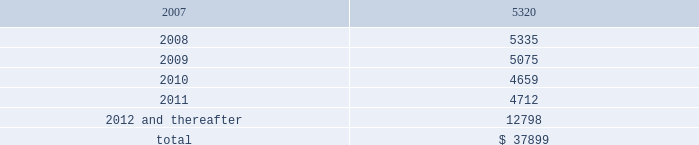As of december 31 , 2006 , the company also leased an office and laboratory facility in connecticut , additional office , distribution and storage facilities in san diego , and four foreign facilities located in japan , singapore , china and the netherlands under non-cancelable operating leases that expire at various times through june 2011 .
These leases contain renewal options ranging from one to five years .
As of december 31 , 2006 , annual future minimum payments under these operating leases were as follows ( in thousands ) : .
Rent expense , net of amortization of the deferred gain on sale of property , was $ 4723041 , $ 4737218 , and $ 1794234 for the years ended december 31 , 2006 , january 1 , 2006 and january 2 , 2005 , respectively .
Stockholders 2019 equity common stock as of december 31 , 2006 , the company had 46857512 shares of common stock outstanding , of which 4814744 shares were sold to employees and consultants subject to restricted stock agreements .
The restricted common shares vest in accordance with the provisions of the agreements , generally over five years .
All unvested shares are subject to repurchase by the company at the original purchase price .
As of december 31 , 2006 , 36000 shares of common stock were subject to repurchase .
In addition , the company also issued 12000 shares for a restricted stock award to an employee under the company 2019s new 2005 stock and incentive plan based on service performance .
These shares vest monthly over a three-year period .
Stock options 2005 stock and incentive plan in june 2005 , the stockholders of the company approved the 2005 stock and incentive plan ( the 2005 stock plan ) .
Upon adoption of the 2005 stock plan , issuance of options under the company 2019s existing 2000 stock plan ceased .
The 2005 stock plan provides that an aggregate of up to 11542358 shares of the company 2019s common stock be reserved and available to be issued .
In addition , the 2005 stock plan provides for an automatic annual increase in the shares reserved for issuance by the lesser of 5% ( 5 % ) of outstanding shares of the company 2019s common stock on the last day of the immediately preceding fiscal year , 1200000 shares or such lesser amount as determined by the company 2019s board of directors .
Illumina , inc .
Notes to consolidated financial statements 2014 ( continued ) .
What percentage of annual future minimum payments under operating leases are due in 2008? 
Computations: (5335 / 37899)
Answer: 0.14077. As of december 31 , 2006 , the company also leased an office and laboratory facility in connecticut , additional office , distribution and storage facilities in san diego , and four foreign facilities located in japan , singapore , china and the netherlands under non-cancelable operating leases that expire at various times through june 2011 .
These leases contain renewal options ranging from one to five years .
As of december 31 , 2006 , annual future minimum payments under these operating leases were as follows ( in thousands ) : .
Rent expense , net of amortization of the deferred gain on sale of property , was $ 4723041 , $ 4737218 , and $ 1794234 for the years ended december 31 , 2006 , january 1 , 2006 and january 2 , 2005 , respectively .
Stockholders 2019 equity common stock as of december 31 , 2006 , the company had 46857512 shares of common stock outstanding , of which 4814744 shares were sold to employees and consultants subject to restricted stock agreements .
The restricted common shares vest in accordance with the provisions of the agreements , generally over five years .
All unvested shares are subject to repurchase by the company at the original purchase price .
As of december 31 , 2006 , 36000 shares of common stock were subject to repurchase .
In addition , the company also issued 12000 shares for a restricted stock award to an employee under the company 2019s new 2005 stock and incentive plan based on service performance .
These shares vest monthly over a three-year period .
Stock options 2005 stock and incentive plan in june 2005 , the stockholders of the company approved the 2005 stock and incentive plan ( the 2005 stock plan ) .
Upon adoption of the 2005 stock plan , issuance of options under the company 2019s existing 2000 stock plan ceased .
The 2005 stock plan provides that an aggregate of up to 11542358 shares of the company 2019s common stock be reserved and available to be issued .
In addition , the 2005 stock plan provides for an automatic annual increase in the shares reserved for issuance by the lesser of 5% ( 5 % ) of outstanding shares of the company 2019s common stock on the last day of the immediately preceding fiscal year , 1200000 shares or such lesser amount as determined by the company 2019s board of directors .
Illumina , inc .
Notes to consolidated financial statements 2014 ( continued ) .
As of december 31 , 2006 , annual future minimum payments under these operating leases what was the percent of the amount in 2007? 
Rationale: as of december 31 , 2006 , 14% of the annual future minimum payments under these operating leases was due 2007
Computations: (5320 / 37899)
Answer: 0.14037. 